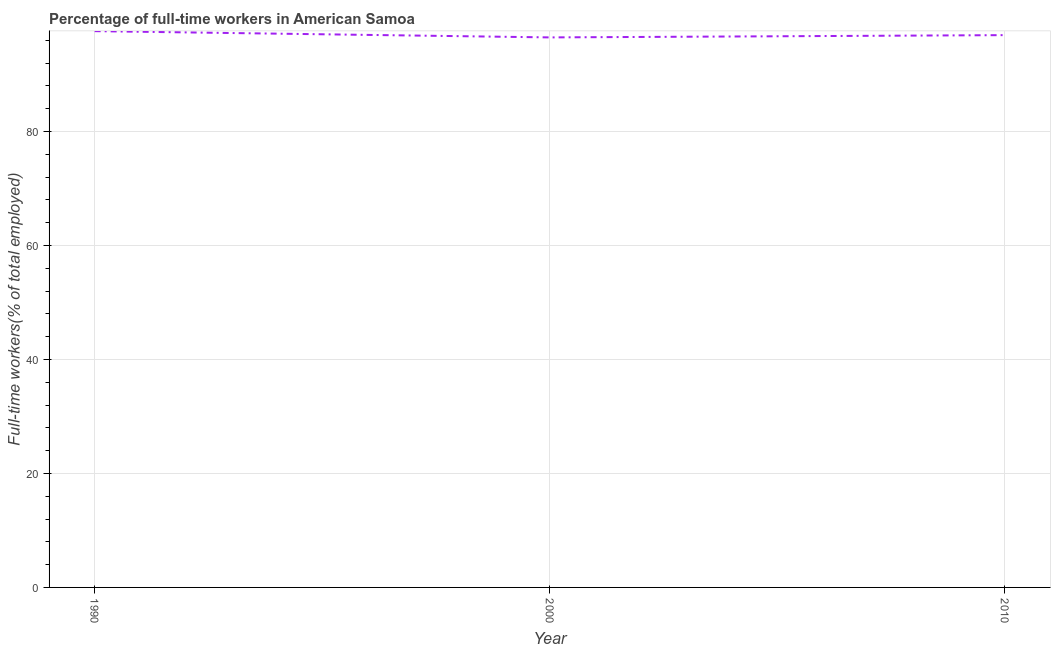What is the percentage of full-time workers in 1990?
Your answer should be compact. 97.6. Across all years, what is the maximum percentage of full-time workers?
Keep it short and to the point. 97.6. Across all years, what is the minimum percentage of full-time workers?
Keep it short and to the point. 96.5. In which year was the percentage of full-time workers maximum?
Provide a short and direct response. 1990. What is the sum of the percentage of full-time workers?
Keep it short and to the point. 291. What is the difference between the percentage of full-time workers in 2000 and 2010?
Provide a short and direct response. -0.4. What is the average percentage of full-time workers per year?
Keep it short and to the point. 97. What is the median percentage of full-time workers?
Offer a terse response. 96.9. Do a majority of the years between 1990 and 2010 (inclusive) have percentage of full-time workers greater than 8 %?
Provide a succinct answer. Yes. What is the ratio of the percentage of full-time workers in 1990 to that in 2000?
Provide a short and direct response. 1.01. Is the percentage of full-time workers in 1990 less than that in 2010?
Provide a succinct answer. No. Is the difference between the percentage of full-time workers in 2000 and 2010 greater than the difference between any two years?
Your response must be concise. No. What is the difference between the highest and the second highest percentage of full-time workers?
Ensure brevity in your answer.  0.7. What is the difference between the highest and the lowest percentage of full-time workers?
Offer a very short reply. 1.1. In how many years, is the percentage of full-time workers greater than the average percentage of full-time workers taken over all years?
Provide a short and direct response. 1. What is the title of the graph?
Your answer should be compact. Percentage of full-time workers in American Samoa. What is the label or title of the Y-axis?
Keep it short and to the point. Full-time workers(% of total employed). What is the Full-time workers(% of total employed) of 1990?
Keep it short and to the point. 97.6. What is the Full-time workers(% of total employed) in 2000?
Provide a succinct answer. 96.5. What is the Full-time workers(% of total employed) in 2010?
Your answer should be very brief. 96.9. What is the difference between the Full-time workers(% of total employed) in 1990 and 2000?
Offer a terse response. 1.1. What is the difference between the Full-time workers(% of total employed) in 1990 and 2010?
Offer a terse response. 0.7. What is the ratio of the Full-time workers(% of total employed) in 2000 to that in 2010?
Offer a terse response. 1. 